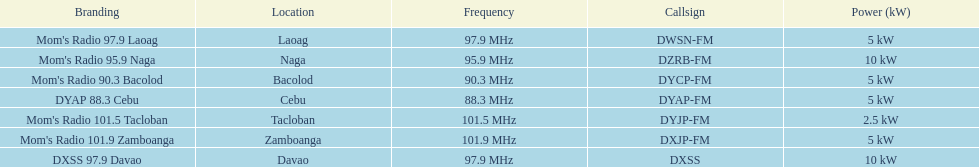How often does the frequency surpass 95? 5. 